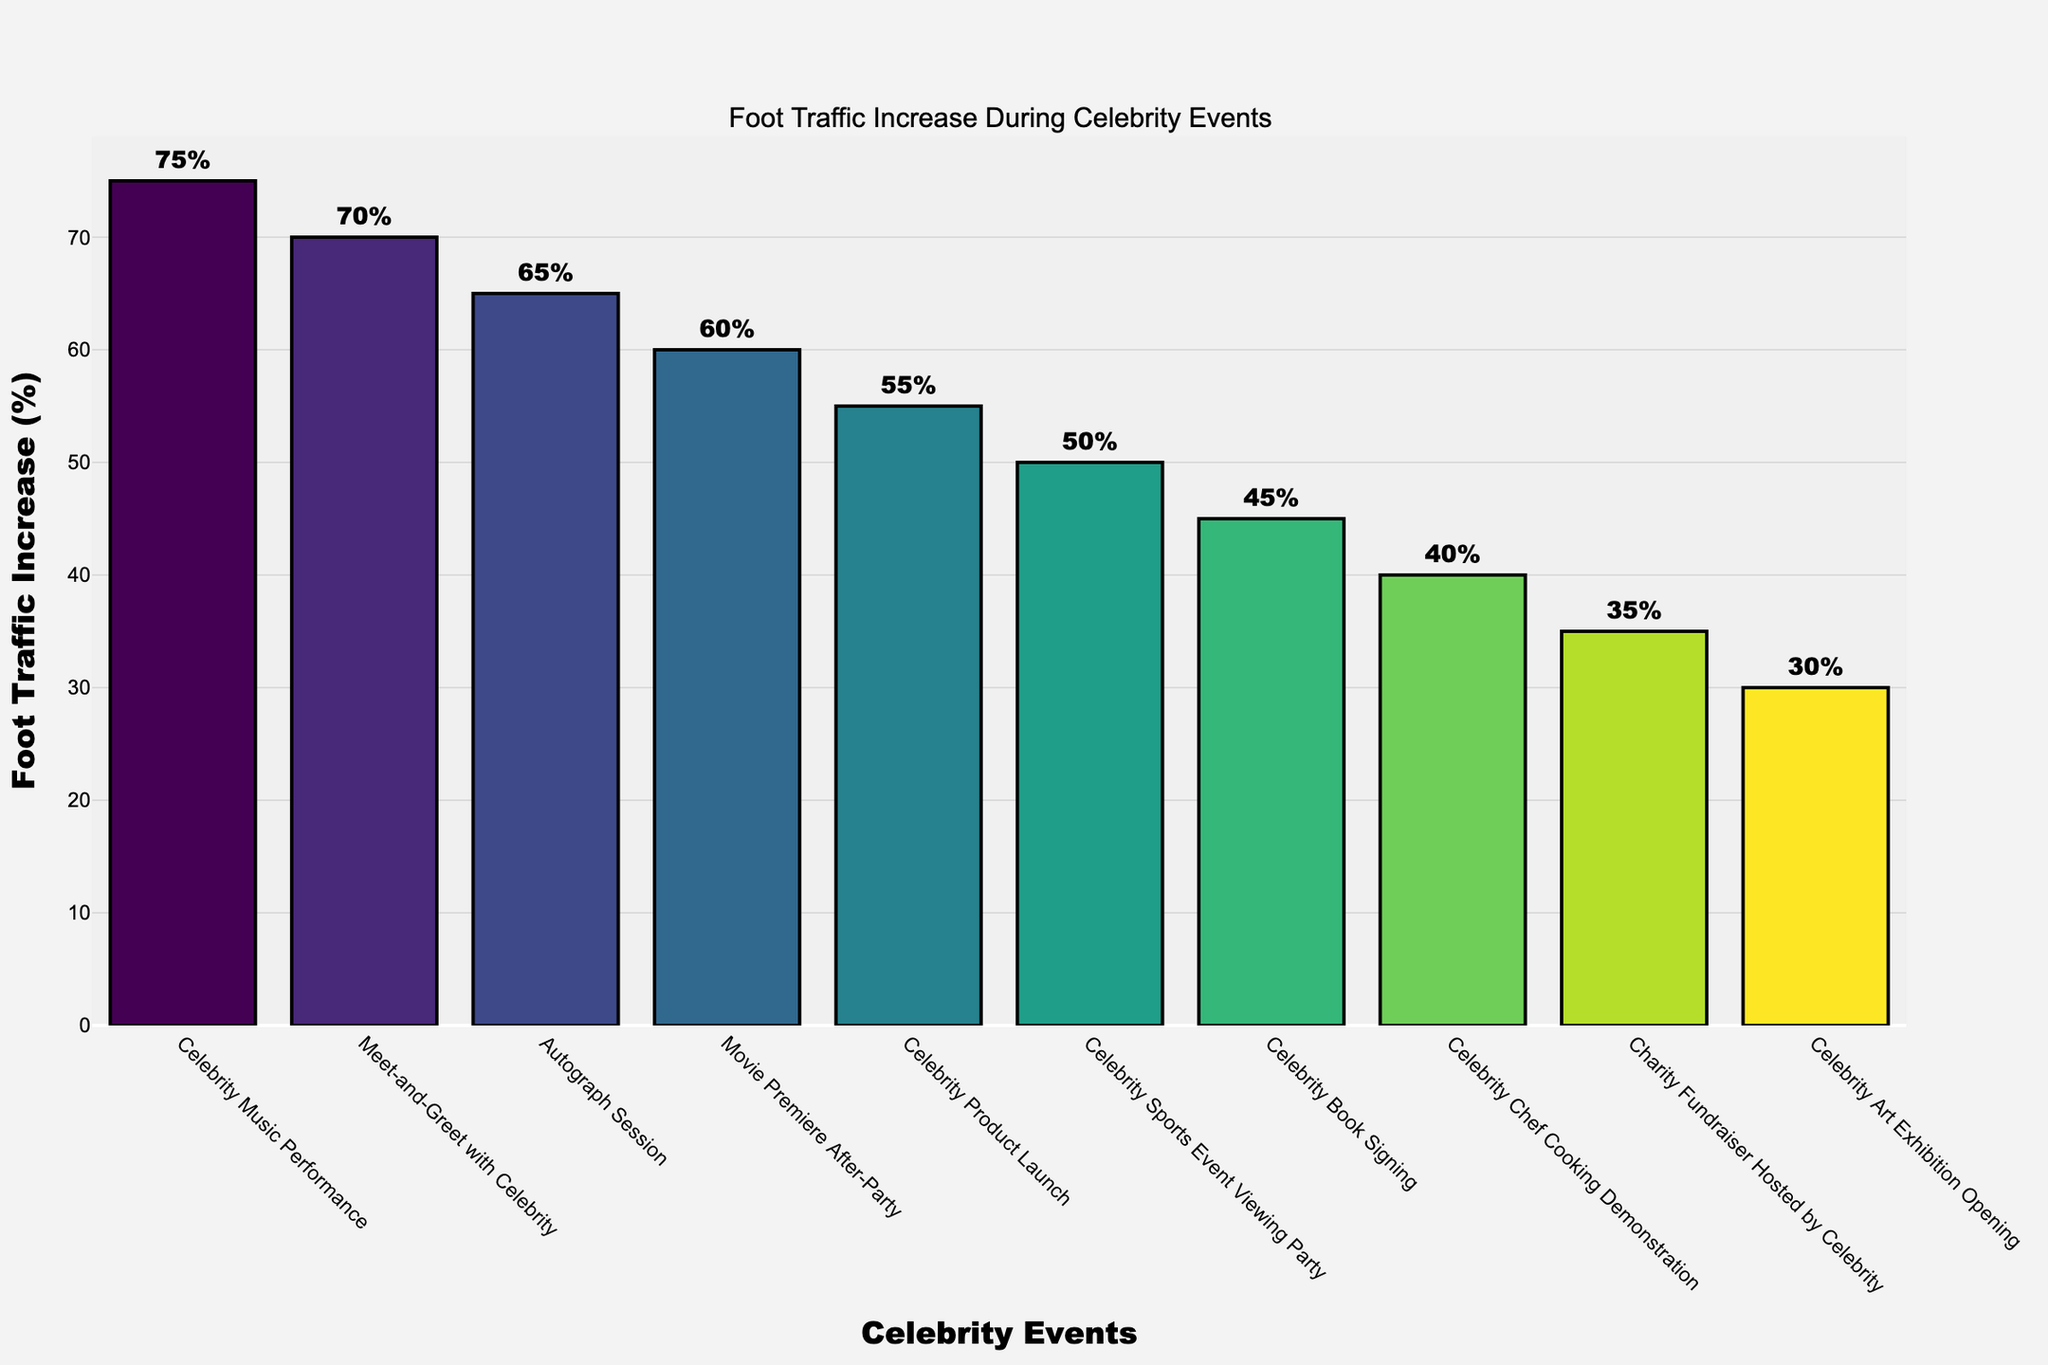What event resulted in the highest foot traffic increase? The bar representing "Celebrity Music Performance" is the tallest, indicating it has the highest foot traffic increase. The hover text confirms a 75% increase.
Answer: Celebrity Music Performance Which event had a higher foot traffic increase: Celebrity Chef Cooking Demonstration or Celebrity Product Launch? By comparing the height of the bars and hover text, "Celebrity Product Launch" had a 55% increase, while "Celebrity Chef Cooking Demonstration" had a 40% increase. Therefore, "Celebrity Product Launch" is higher.
Answer: Celebrity Product Launch What are the top three events that had the greatest foot traffic increase? The top three bars in decreasing order of height represent: Celebrity Music Performance (75%), Meet-and-Greet with Celebrity (70%), and Autograph Session (65%).
Answer: Celebrity Music Performance, Meet-and-Greet with Celebrity, Autograph Session What is the sum of the foot traffic increases for the Movie Premiere After-Party and Autograph Session? Movie Premiere After-Party had a 60% increase and Autograph Session had a 65% increase. Adding these together: 60 + 65 = 125.
Answer: 125 Which event had the lowest foot traffic increase? The shortest bar on the chart represents "Celebrity Art Exhibition Opening," with a 30% increase.
Answer: Celebrity Art Exhibition Opening What is the average foot traffic increase for all events? Sum all foot traffic increases: 45 + 60 + 35 + 55 + 70 + 40 + 65 + 50 + 30 + 75 = 525. There are 10 events: 525 / 10 = 52.5.
Answer: 52.5 Are there more events with a foot traffic increase above or below 50%? There are six events with increases above 50% (Celebrity Music Performance, Meet-and-Greet with Celebrity, Autograph Session, Movie Premiere After-Party, Celebrity Product Launch, Celebrity Sports Event Viewing Party), and four events below 50% (Celebrity Book Signing, Charity Fundraiser Hosted by Celebrity, Celebrity Chef Cooking Demonstration, Celebrity Art Exhibition Opening).
Answer: Above Which two events have a foot traffic increase difference of exactly 15%? Comparing pairs of hover text values, "Movie Premiere After-Party" (60%) and "Celebrity Sports Event Viewing Party" (50%) have a difference of 10%. Similarly, "Celebrity Chef Cooking Demonstration" (40%) and "Celebrity Art Exhibition Opening" (30%) have a difference of 10%. None have exactly 15%.
Answer: None Is there any event with a foot traffic increase exactly equal to the average increase? Calculate the average foot traffic increase (52.5%) and compare it to the hover text of each bar. None of the events have an increase exactly equal to 52.5%.
Answer: No Which event associated with book signing had an increase, and what was the percent increase? The bar labeled "Celebrity Book Signing" showed a 45% increase according to the hover text.
Answer: Celebrity Book Signing, 45% 